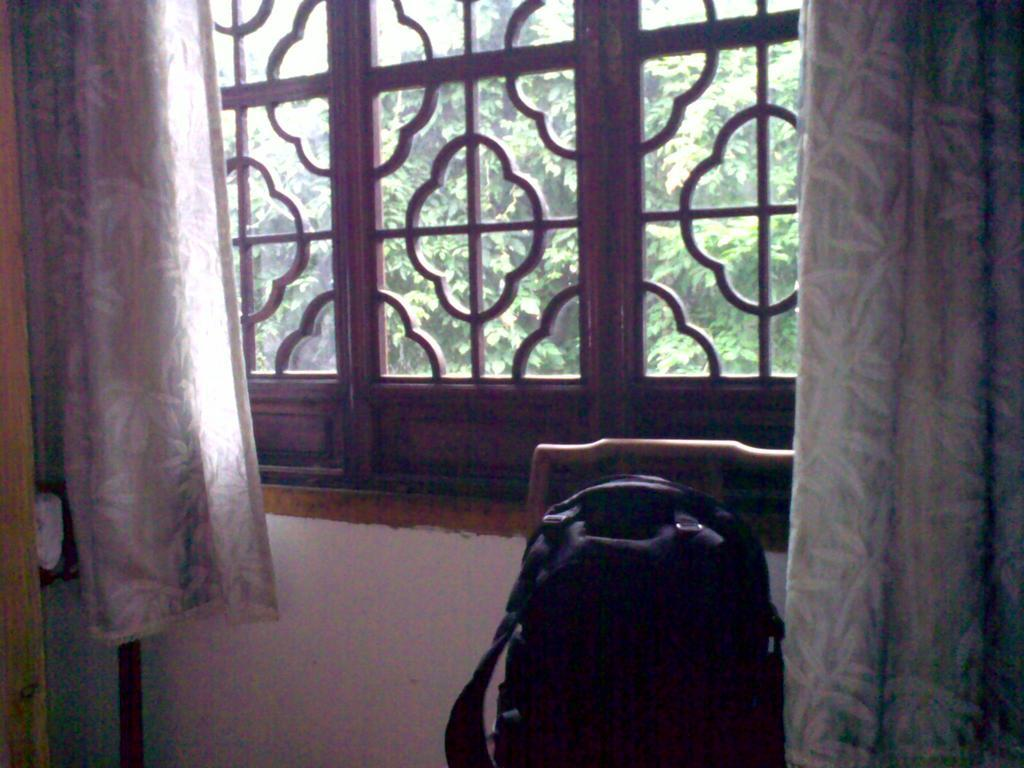What piece of furniture is present in the image? There is a chair in the image. What is placed on the chair? There is a bag on the chair. What can be seen in the background of the image? There is a window in the backdrop of the image. What is associated with the window? There is a curtain associated with the window. What is visible from the window? Trees are visible from the window. What type of club can be seen in the image? There is no club present in the image. Are there any bears visible in the image? There are no bears present in the image. 